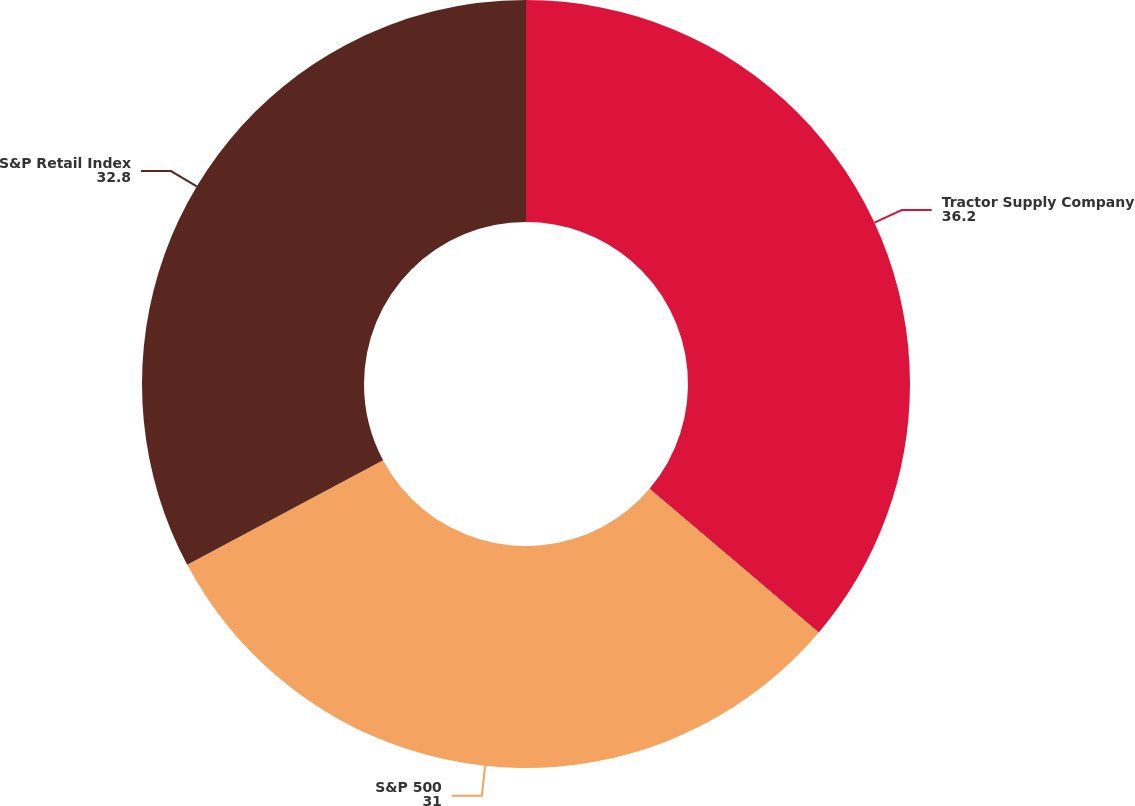Convert chart to OTSL. <chart><loc_0><loc_0><loc_500><loc_500><pie_chart><fcel>Tractor Supply Company<fcel>S&P 500<fcel>S&P Retail Index<nl><fcel>36.2%<fcel>31.0%<fcel>32.8%<nl></chart> 